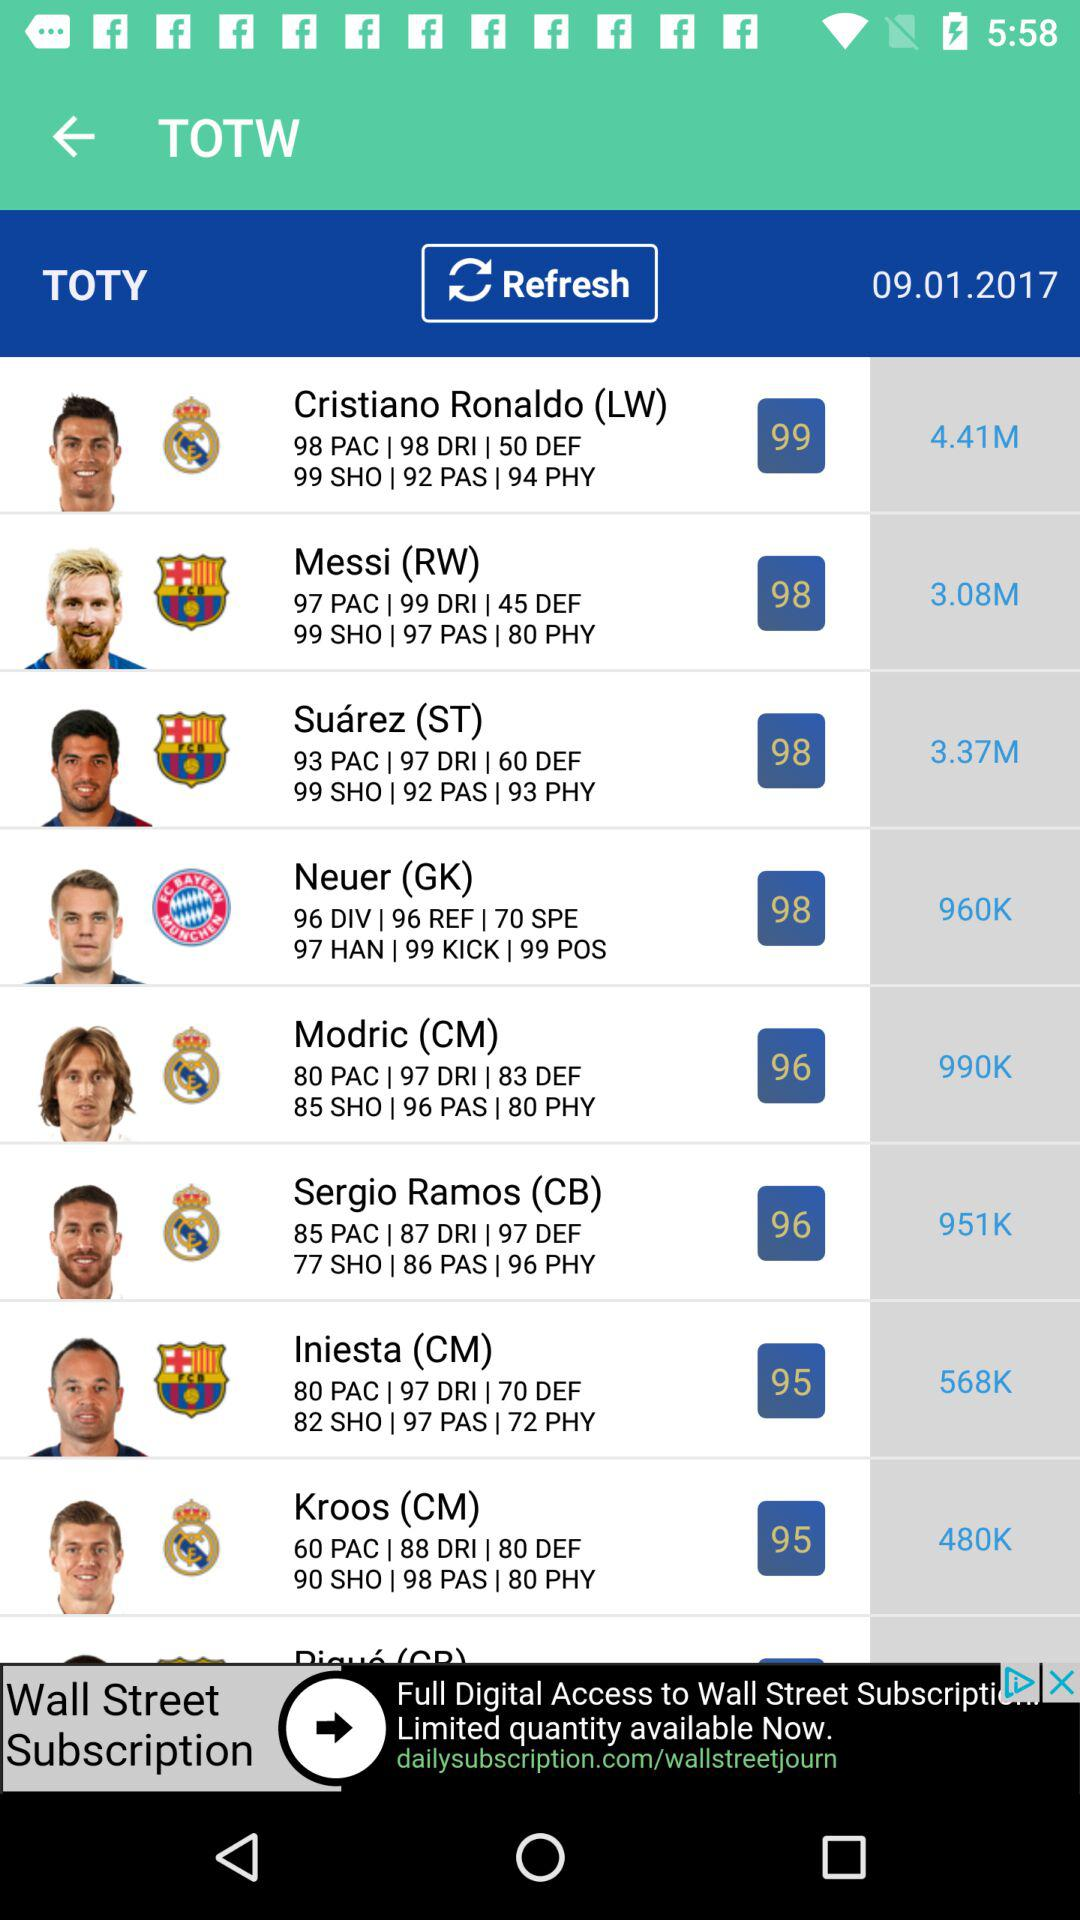What is the date for TOTY? The date is September 1, 2017. 